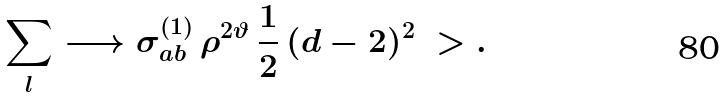<formula> <loc_0><loc_0><loc_500><loc_500>\sum _ { l } \longrightarrow \sigma _ { a b } ^ { ( 1 ) } \, \rho ^ { 2 \vartheta } \, \frac { 1 } { 2 } \, ( d - 2 ) ^ { 2 } \ > .</formula> 